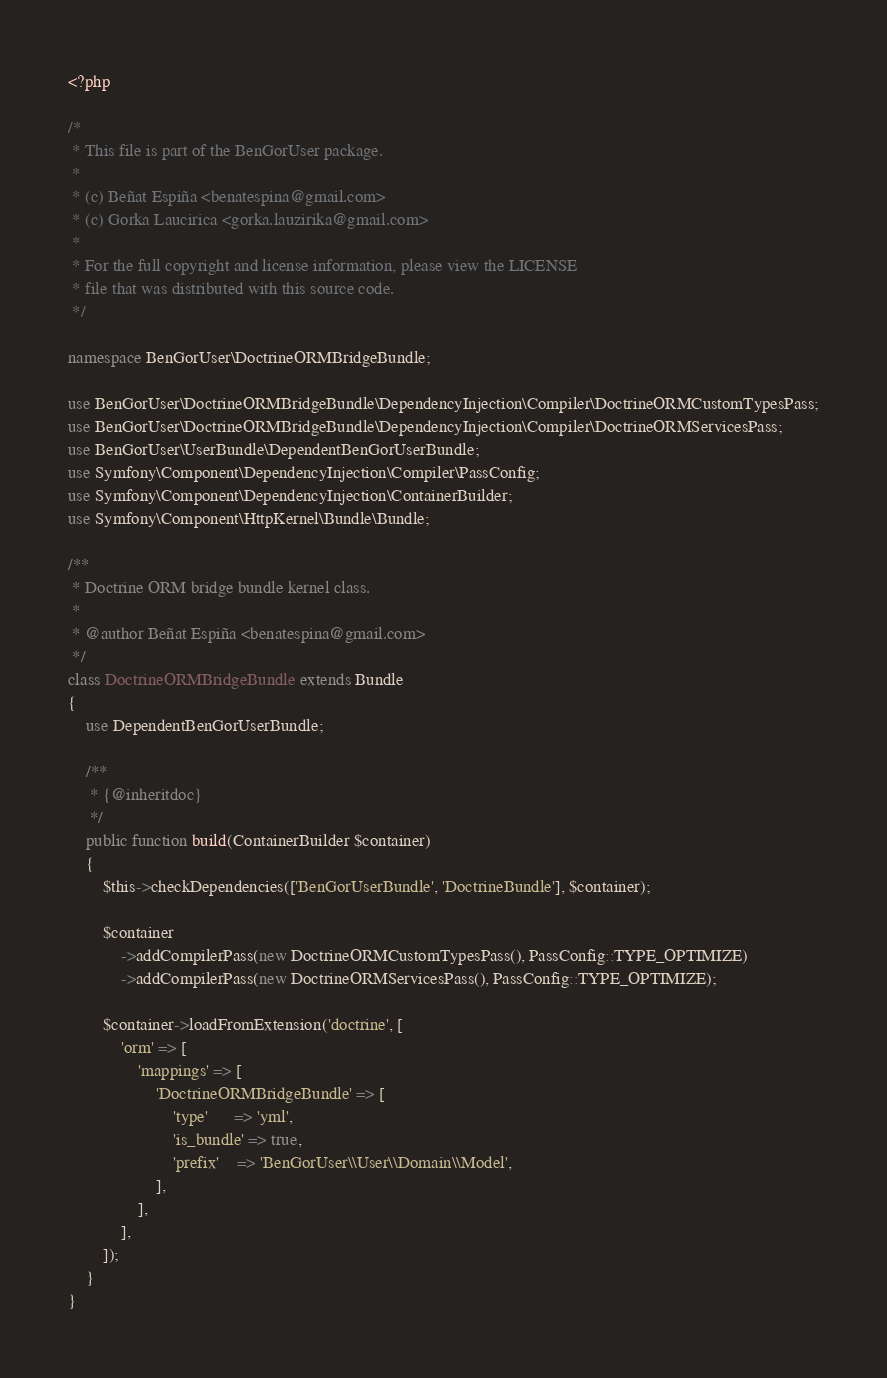Convert code to text. <code><loc_0><loc_0><loc_500><loc_500><_PHP_><?php

/*
 * This file is part of the BenGorUser package.
 *
 * (c) Beñat Espiña <benatespina@gmail.com>
 * (c) Gorka Laucirica <gorka.lauzirika@gmail.com>
 *
 * For the full copyright and license information, please view the LICENSE
 * file that was distributed with this source code.
 */

namespace BenGorUser\DoctrineORMBridgeBundle;

use BenGorUser\DoctrineORMBridgeBundle\DependencyInjection\Compiler\DoctrineORMCustomTypesPass;
use BenGorUser\DoctrineORMBridgeBundle\DependencyInjection\Compiler\DoctrineORMServicesPass;
use BenGorUser\UserBundle\DependentBenGorUserBundle;
use Symfony\Component\DependencyInjection\Compiler\PassConfig;
use Symfony\Component\DependencyInjection\ContainerBuilder;
use Symfony\Component\HttpKernel\Bundle\Bundle;

/**
 * Doctrine ORM bridge bundle kernel class.
 *
 * @author Beñat Espiña <benatespina@gmail.com>
 */
class DoctrineORMBridgeBundle extends Bundle
{
    use DependentBenGorUserBundle;

    /**
     * {@inheritdoc}
     */
    public function build(ContainerBuilder $container)
    {
        $this->checkDependencies(['BenGorUserBundle', 'DoctrineBundle'], $container);

        $container
            ->addCompilerPass(new DoctrineORMCustomTypesPass(), PassConfig::TYPE_OPTIMIZE)
            ->addCompilerPass(new DoctrineORMServicesPass(), PassConfig::TYPE_OPTIMIZE);

        $container->loadFromExtension('doctrine', [
            'orm' => [
                'mappings' => [
                    'DoctrineORMBridgeBundle' => [
                        'type'      => 'yml',
                        'is_bundle' => true,
                        'prefix'    => 'BenGorUser\\User\\Domain\\Model',
                    ],
                ],
            ],
        ]);
    }
}
</code> 